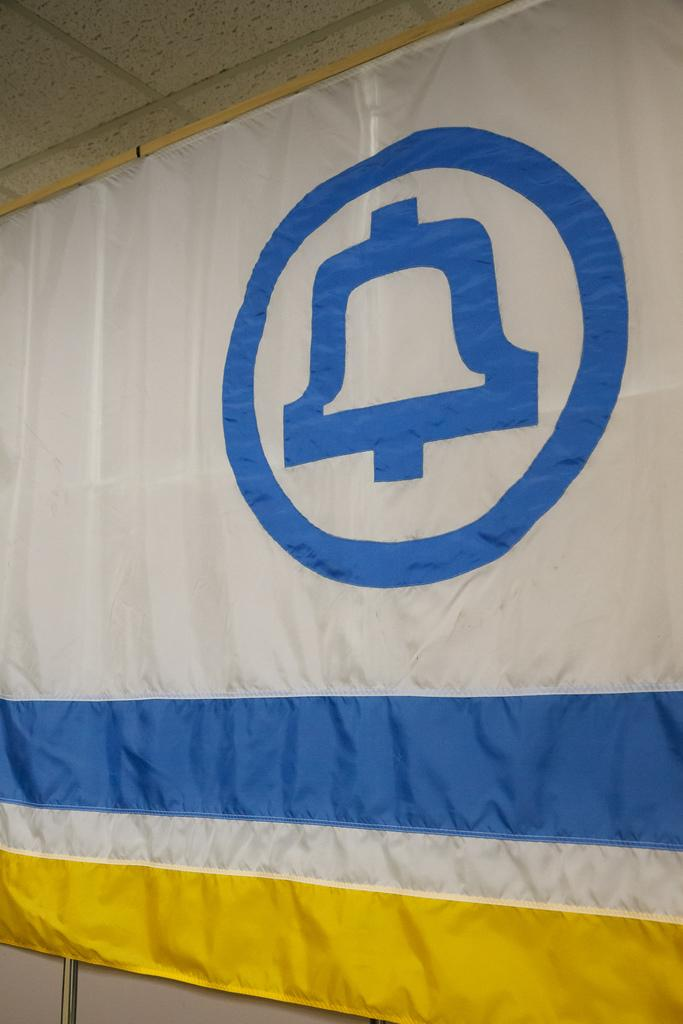What is present in the image that represents a country or organization? There is a flag in the image. What design element can be seen on the flag? The flag has a logo on it. What type of cannon is used by the secretary in the image? There is no cannon or secretary present in the image; it only features a flag with a logo on it. 